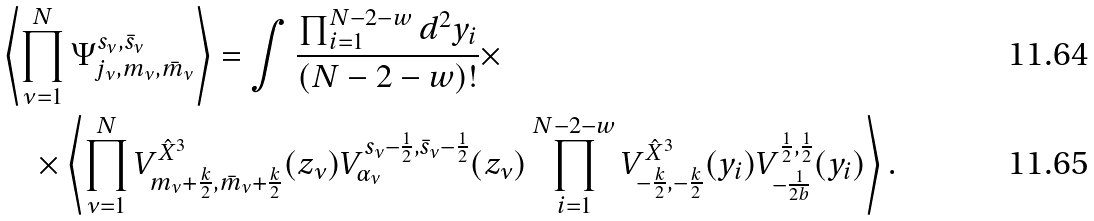<formula> <loc_0><loc_0><loc_500><loc_500>& \left \langle \prod _ { \nu = 1 } ^ { N } \Psi ^ { s _ { \nu } , \bar { s } _ { \nu } } _ { j _ { \nu } , m _ { \nu } , \bar { m } _ { \nu } } \right \rangle = \int \frac { \prod _ { i = 1 } ^ { N - 2 - w } d ^ { 2 } y _ { i } } { ( N - 2 - w ) ! } \times \\ & \quad \times \left \langle \prod _ { \nu = 1 } ^ { N } V ^ { \hat { X } ^ { 3 } } _ { m _ { \nu } + \frac { k } { 2 } , \bar { m } _ { \nu } + \frac { k } { 2 } } ( z _ { \nu } ) V ^ { s _ { \nu } - \frac { 1 } { 2 } , \bar { s } _ { \nu } - \frac { 1 } { 2 } } _ { \alpha _ { \nu } } ( z _ { \nu } ) \prod _ { i = 1 } ^ { N - 2 - w } V ^ { \hat { X } ^ { 3 } } _ { - \frac { k } { 2 } , - \frac { k } { 2 } } ( y _ { i } ) V ^ { \frac { 1 } { 2 } , \frac { 1 } { 2 } } _ { - \frac { 1 } { 2 b } } ( y _ { i } ) \right \rangle .</formula> 